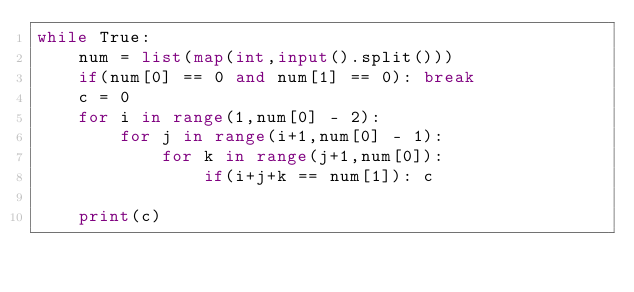<code> <loc_0><loc_0><loc_500><loc_500><_Python_>while True:
    num = list(map(int,input().split()))
    if(num[0] == 0 and num[1] == 0): break
    c = 0
    for i in range(1,num[0] - 2):
        for j in range(i+1,num[0] - 1):
            for k in range(j+1,num[0]):
                if(i+j+k == num[1]): c
    
    print(c)
</code> 